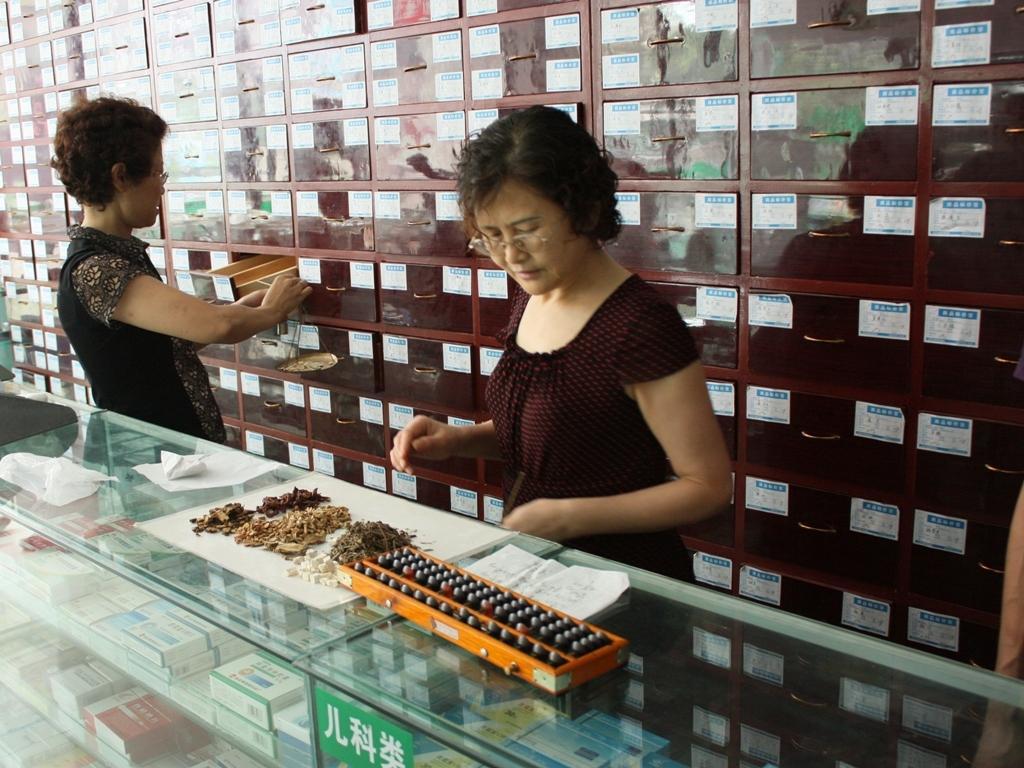In one or two sentences, can you explain what this image depicts? In this image we can see two persons standing. Behind the persons we can see a group of racks. In the front we can see few objects on a glass surface. 